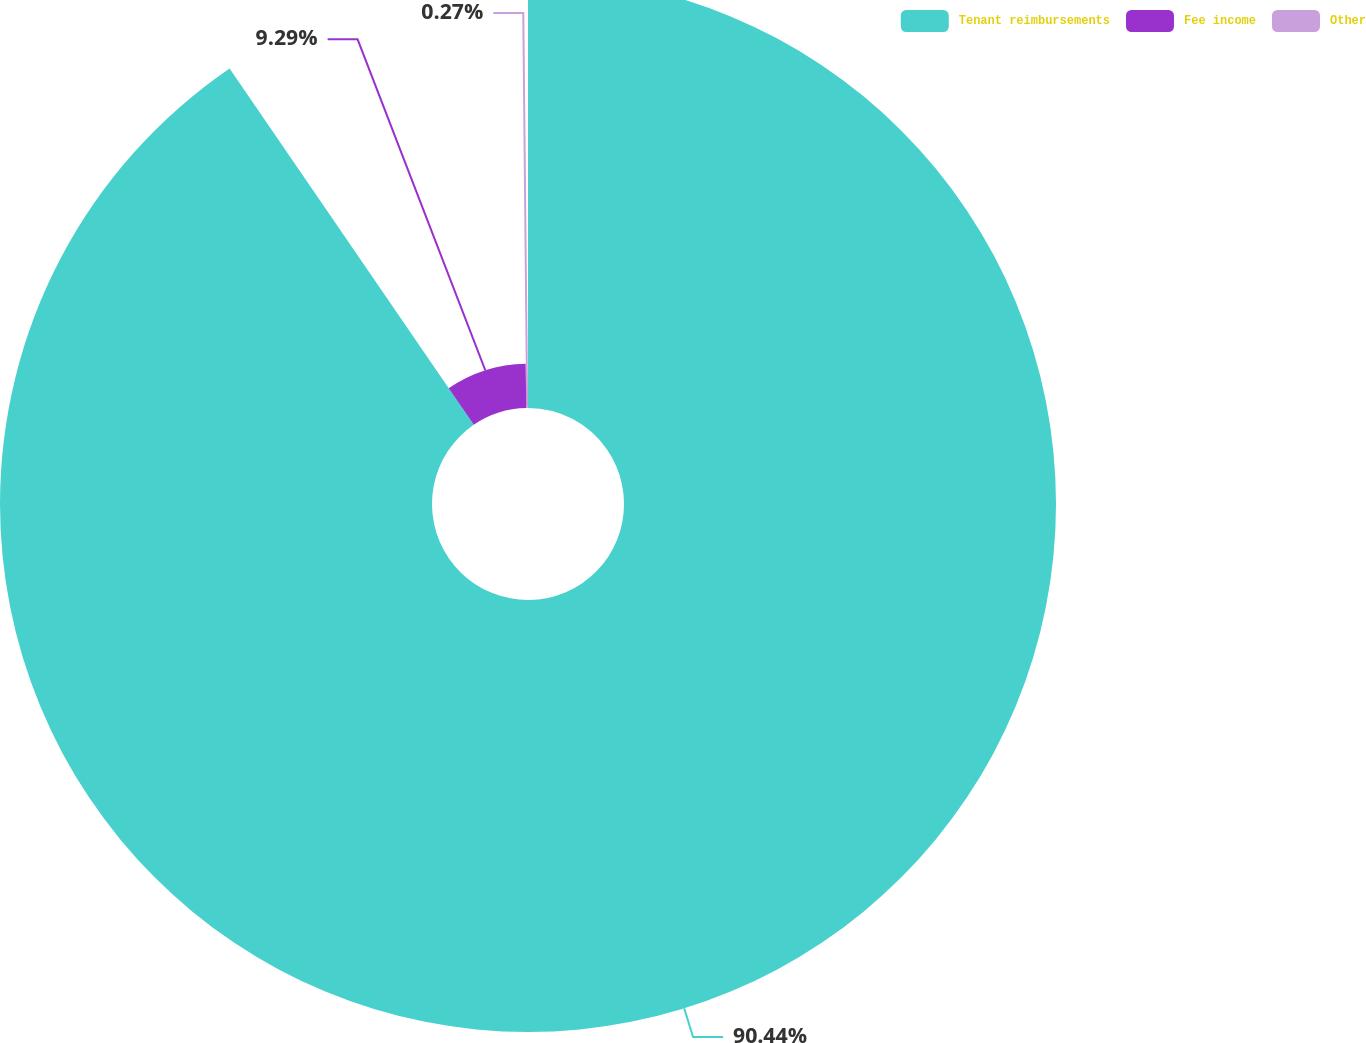Convert chart. <chart><loc_0><loc_0><loc_500><loc_500><pie_chart><fcel>Tenant reimbursements<fcel>Fee income<fcel>Other<nl><fcel>90.44%<fcel>9.29%<fcel>0.27%<nl></chart> 